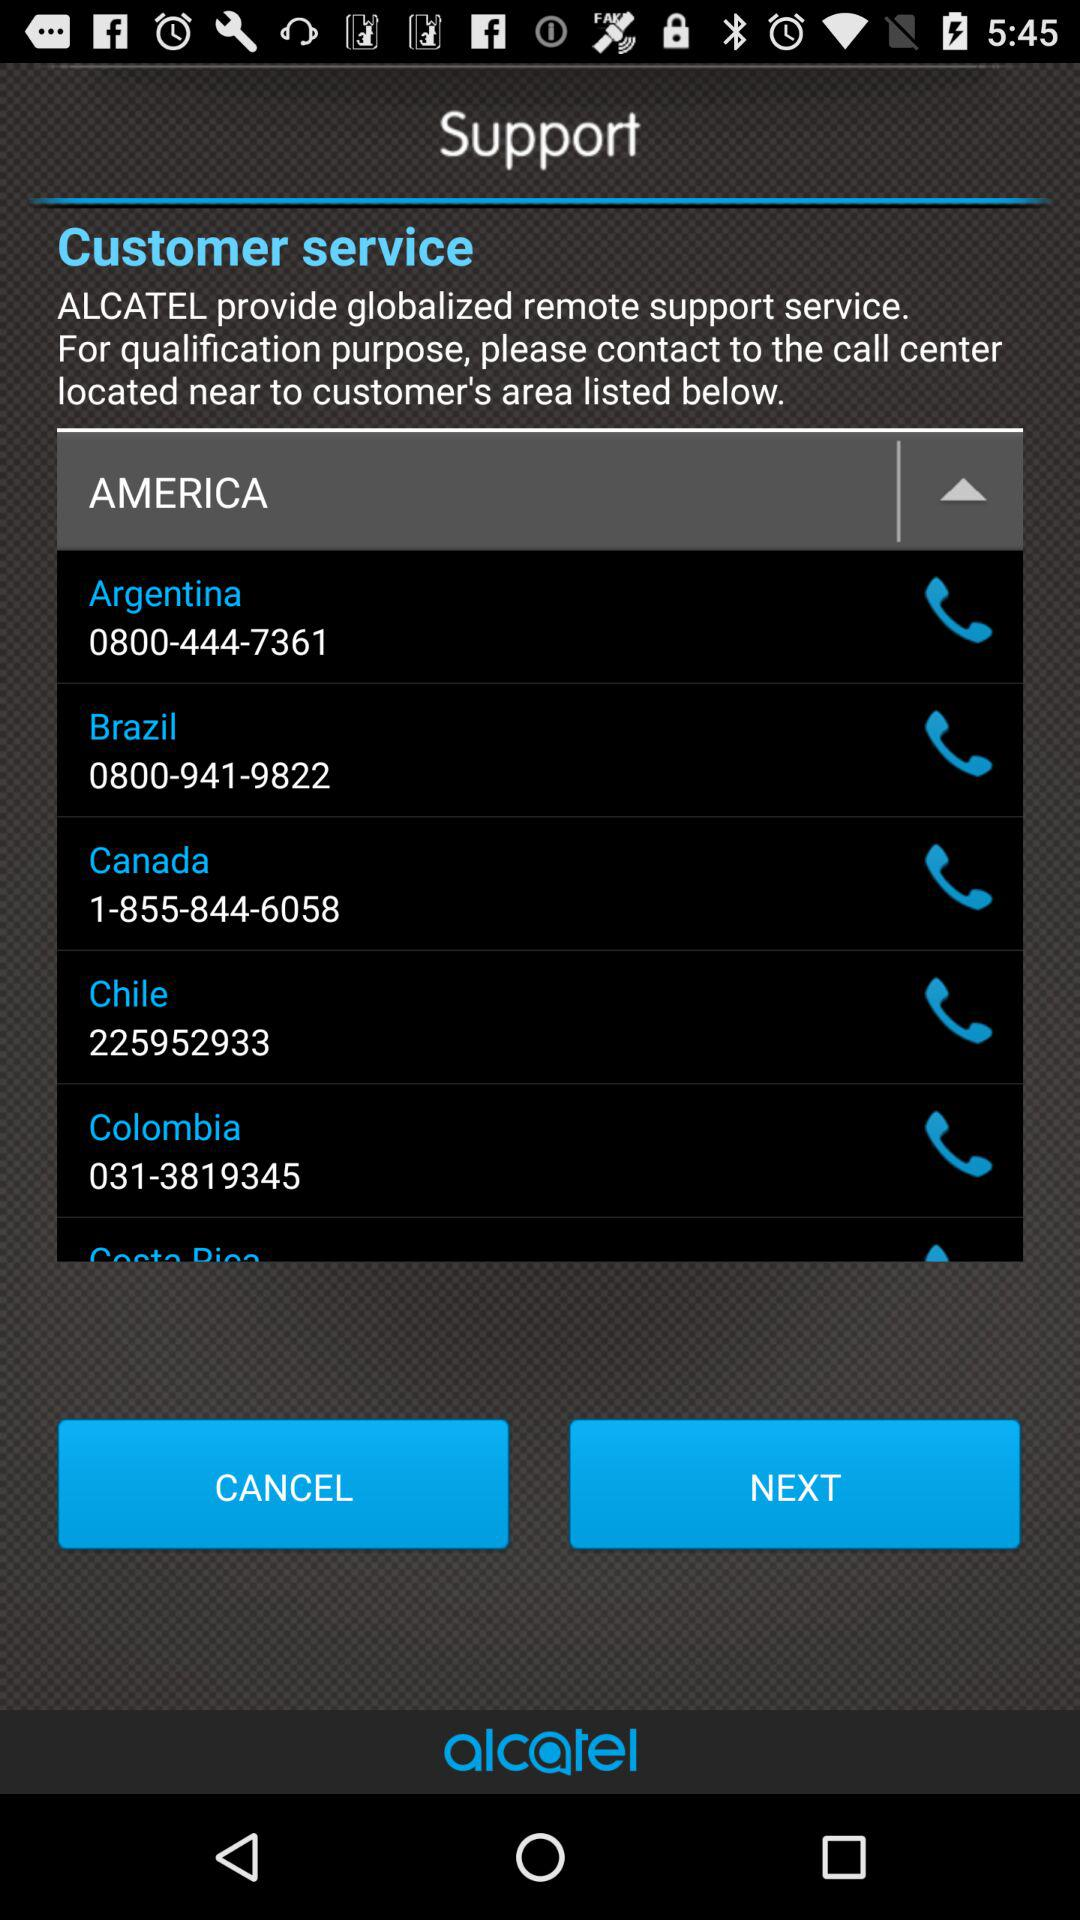What is Canada's phone number? Canada's phone number is 1-855-844-6058. 